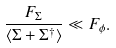Convert formula to latex. <formula><loc_0><loc_0><loc_500><loc_500>\frac { F _ { \Sigma } } { \langle \Sigma + \Sigma ^ { \dagger } \rangle } \ll F _ { \phi } .</formula> 